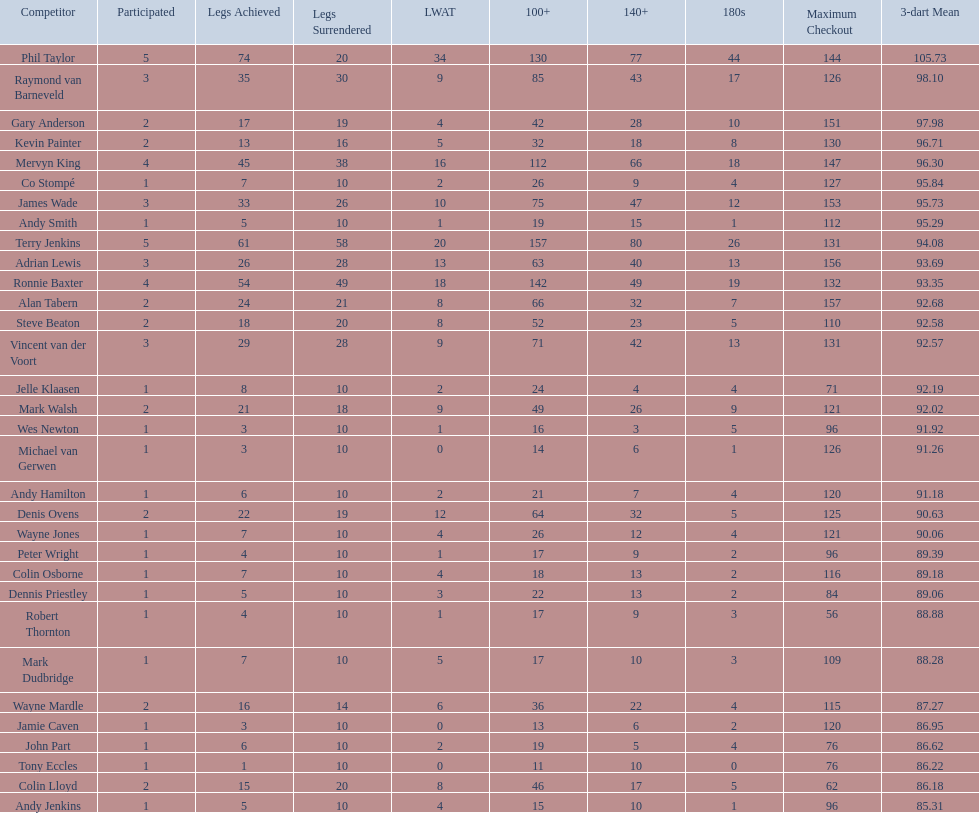Mark walsh's average is above/below 93? Below. 